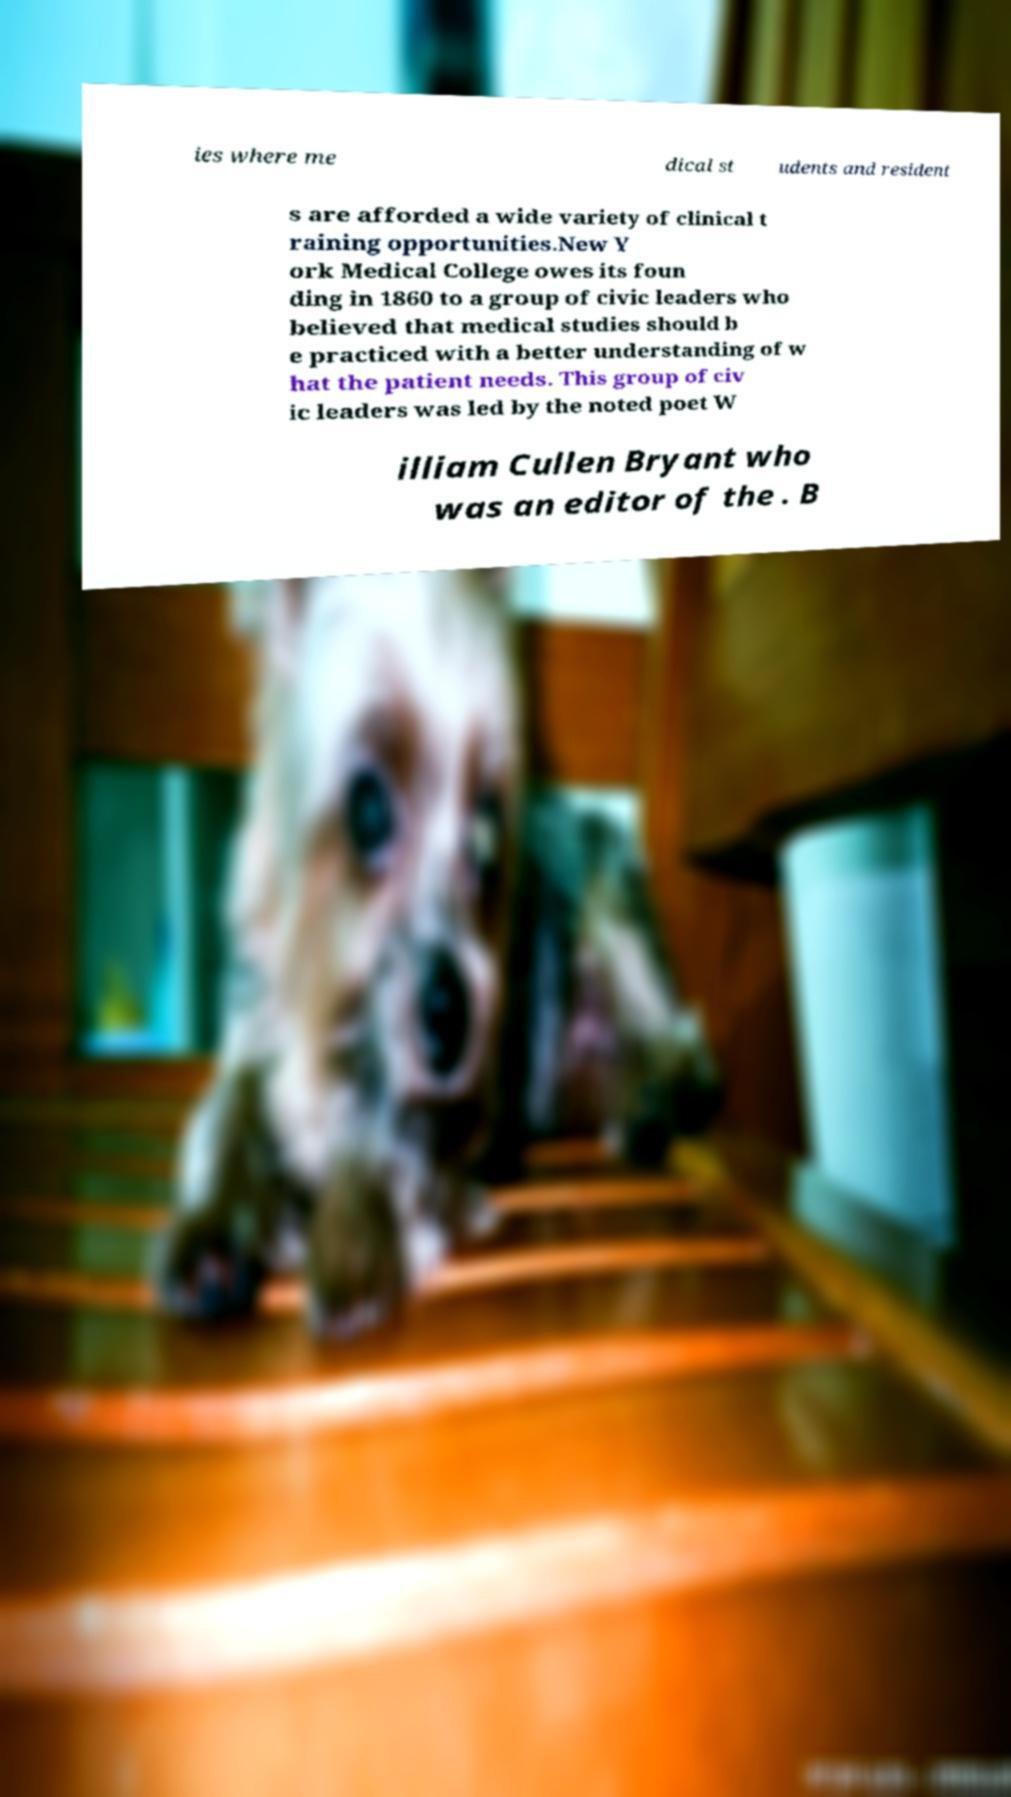Can you accurately transcribe the text from the provided image for me? ies where me dical st udents and resident s are afforded a wide variety of clinical t raining opportunities.New Y ork Medical College owes its foun ding in 1860 to a group of civic leaders who believed that medical studies should b e practiced with a better understanding of w hat the patient needs. This group of civ ic leaders was led by the noted poet W illiam Cullen Bryant who was an editor of the . B 